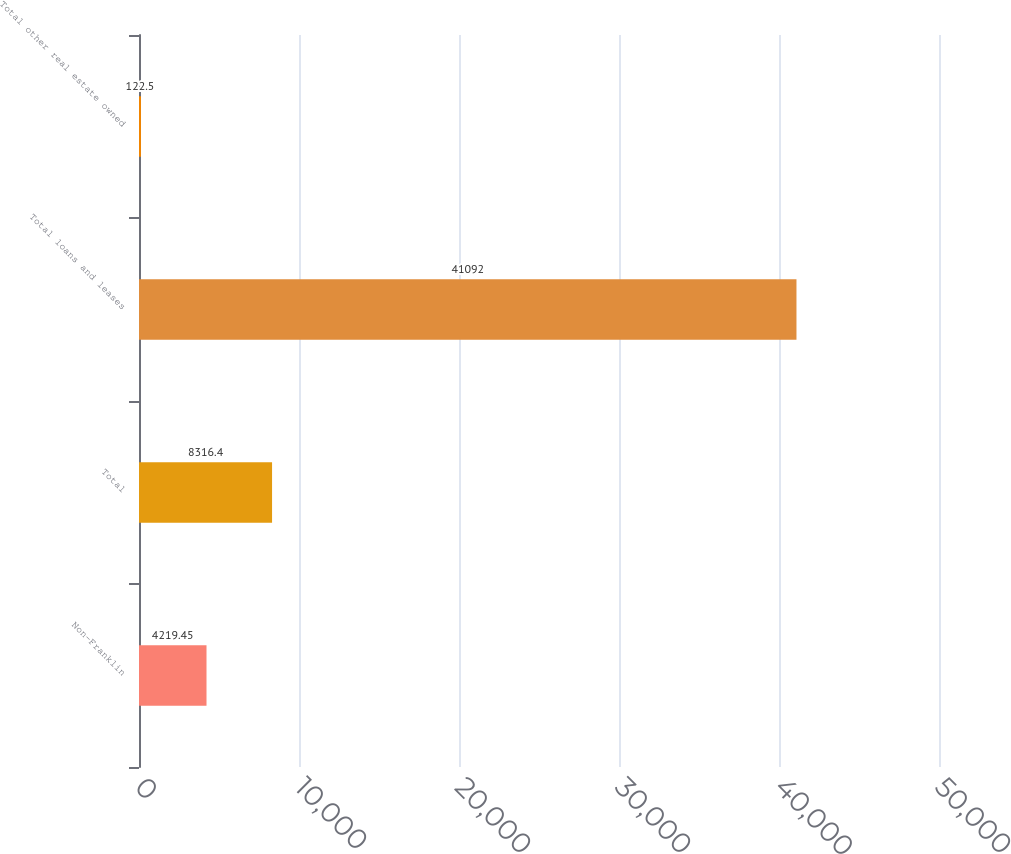Convert chart to OTSL. <chart><loc_0><loc_0><loc_500><loc_500><bar_chart><fcel>Non-Franklin<fcel>Total<fcel>Total loans and leases<fcel>Total other real estate owned<nl><fcel>4219.45<fcel>8316.4<fcel>41092<fcel>122.5<nl></chart> 